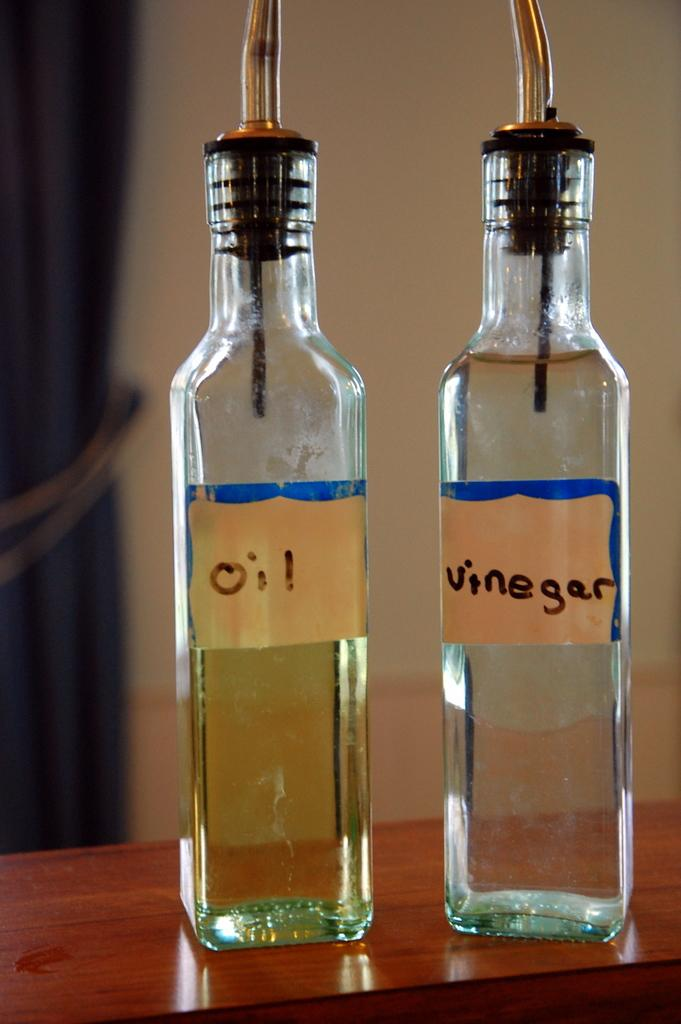<image>
Describe the image concisely. Bottles of oil and vinegar sit on a wooden counter. 